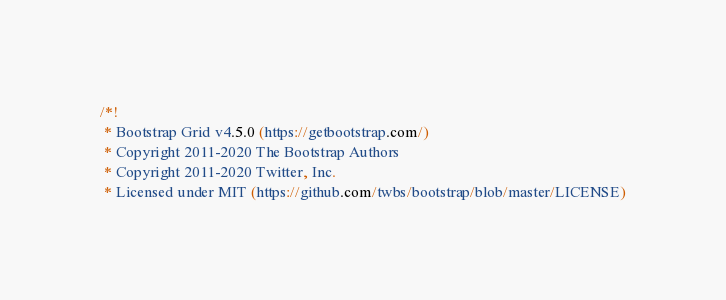Convert code to text. <code><loc_0><loc_0><loc_500><loc_500><_CSS_>/*!
 * Bootstrap Grid v4.5.0 (https://getbootstrap.com/)
 * Copyright 2011-2020 The Bootstrap Authors
 * Copyright 2011-2020 Twitter, Inc.
 * Licensed under MIT (https://github.com/twbs/bootstrap/blob/master/LICENSE)</code> 